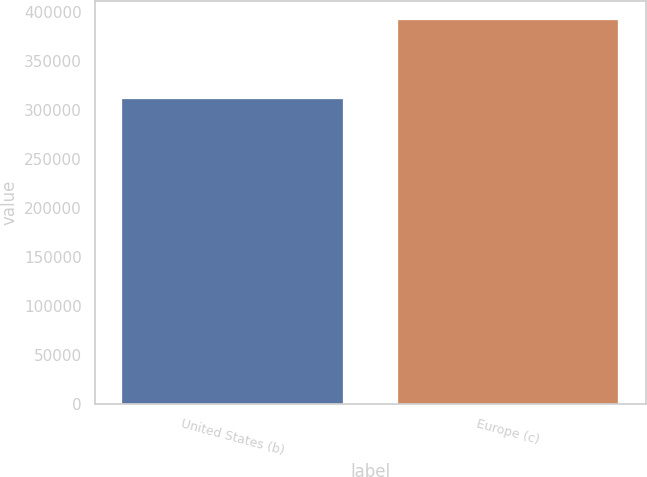<chart> <loc_0><loc_0><loc_500><loc_500><bar_chart><fcel>United States (b)<fcel>Europe (c)<nl><fcel>311710<fcel>391936<nl></chart> 